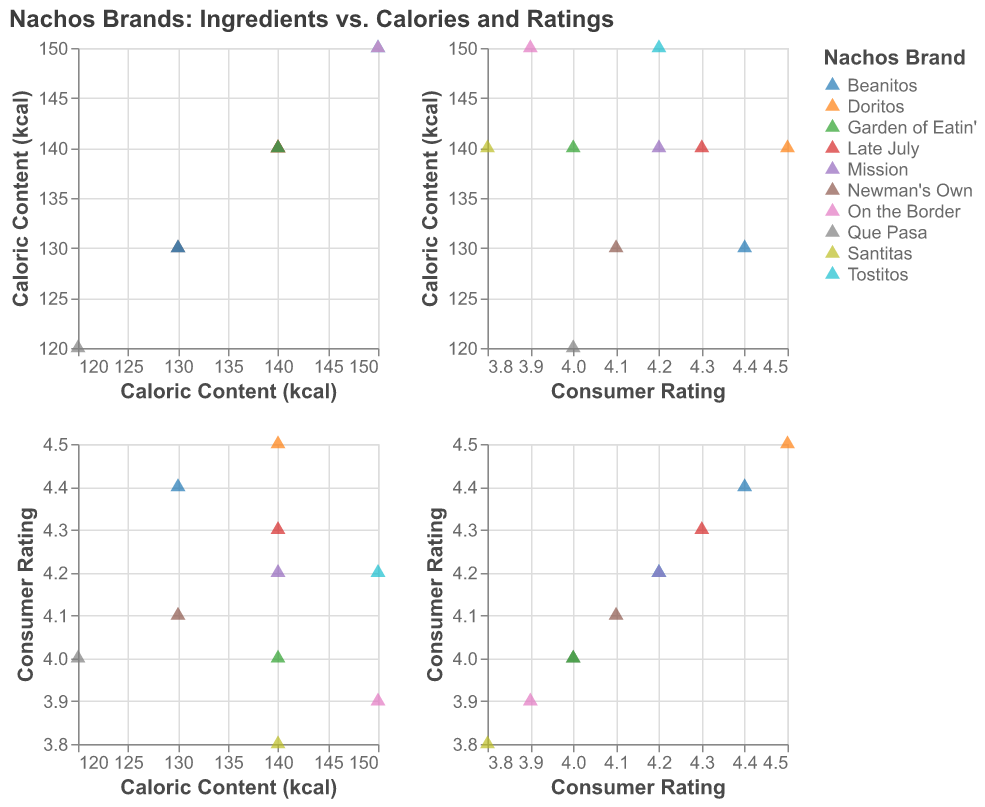What is the title of the figure? The title is displayed prominently at the top of the figure and provides a summary of what the figure represents.
Answer: "Nachos Brands: Ingredients vs. Calories and Ratings" How many nachos brands are represented in the figure? By counting the unique colors or labels corresponding to each nacho brand in the legend or the scatter plot points.
Answer: 10 Which nacho brand has the highest consumer rating and what is that rating? Look for the data point with the highest value on the y-axis labeled "Consumer Rating". The tooltip or legend will help identify the brand.
Answer: Doritos, 4.5 What range of caloric content is covered by the nacho brands? Identify the minimum and maximum values on the x-axis labeled "Caloric Content (kcal)".
Answer: 120 to 150 kcal How many brands have a caloric content of 140 kcal? Locate the points on the plot where the x-coordinate is 140 on the "Caloric Content (kcal)" axis and count them.
Answer: 5 Which brands have both the same caloric content and the consumer rating? Identify points that share the same x and y coordinates on both axes. You may need to reference the tooltip information to match these coordinates.
Answer: Tostitos and Mission (150 kcal, 4.2 rating), Que Pasa and Garden of Eatin' (120 kcal, 4.0 rating) What is the average consumer rating of all the nacho brands? Sum up all the consumer ratings and divide by the number of brands.
Answer: (4.5 + 4.2 + 3.8 + 3.9 + 4.1 + 4.3 + 4.0 + 4.2 + 4.4 + 4.0) / 10 = 4.14 Compare the caloric content of Beanitos and Late July. Which one is higher? Check the x-axis positions of Beanitos and Late July and compare their caloric content values.
Answer: Late July, 140 kcal (vs. Beanitos, 130 kcal) Are there any brands with a consumer rating below 4.0? If so, which ones? Look for data points with a y-coordinate (consumer rating) below 4.0 and identify the corresponding brands.
Answer: Santitas, On the Border What is the typical combination of ingredients among the nacho brands? Find the most common ingredients listed in the tooltip information for Ingredient1, Ingredient2, and Ingredient3 across different brands.
Answer: Corn, Vegetable Oil, Salt 